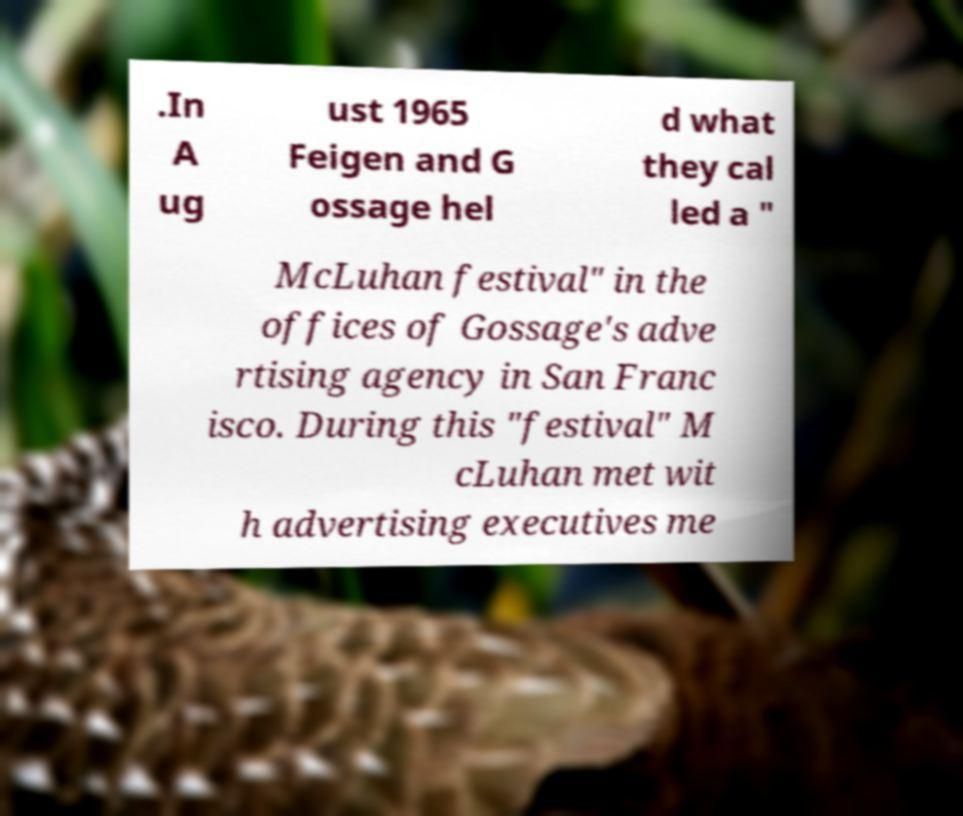For documentation purposes, I need the text within this image transcribed. Could you provide that? .In A ug ust 1965 Feigen and G ossage hel d what they cal led a " McLuhan festival" in the offices of Gossage's adve rtising agency in San Franc isco. During this "festival" M cLuhan met wit h advertising executives me 